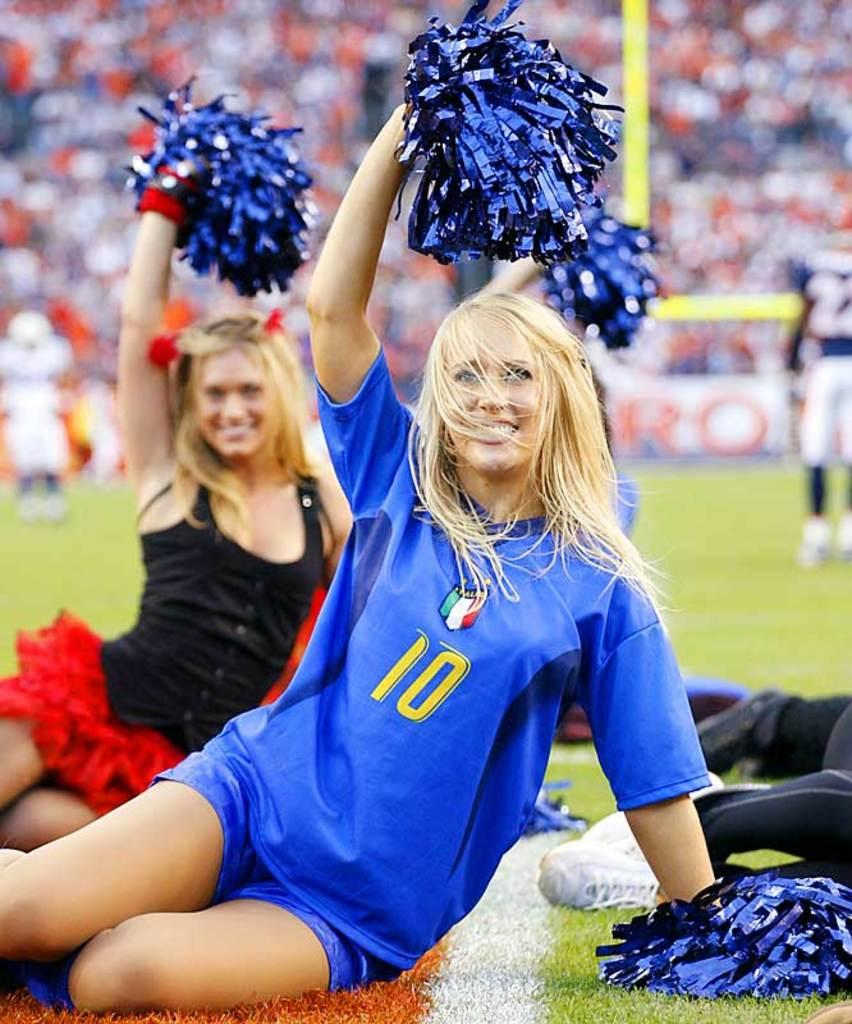Provide a one-sentence caption for the provided image. The cheerleader's blue short sleeve shirt has the number 10 on the front. 